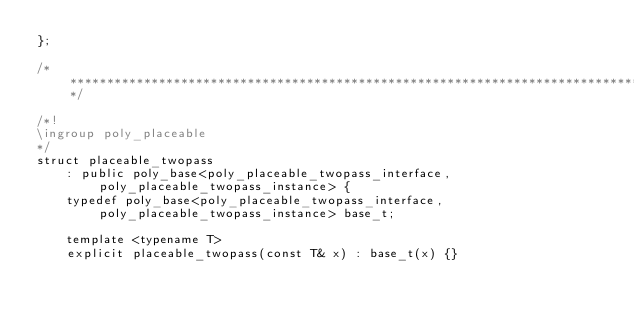<code> <loc_0><loc_0><loc_500><loc_500><_C++_>};

/**************************************************************************************************/

/*!
\ingroup poly_placeable
*/
struct placeable_twopass
    : public poly_base<poly_placeable_twopass_interface, poly_placeable_twopass_instance> {
    typedef poly_base<poly_placeable_twopass_interface, poly_placeable_twopass_instance> base_t;

    template <typename T>
    explicit placeable_twopass(const T& x) : base_t(x) {}
</code> 